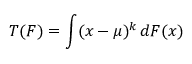Convert formula to latex. <formula><loc_0><loc_0><loc_500><loc_500>T ( F ) = \int ( x - \mu ) ^ { k } \, d F ( x )</formula> 